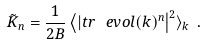Convert formula to latex. <formula><loc_0><loc_0><loc_500><loc_500>\tilde { K } _ { n } = \frac { 1 } { 2 B } \left \langle | t r \, \ e v o l ( k ) ^ { n } \right | ^ { 2 } \rangle _ { k } \ .</formula> 